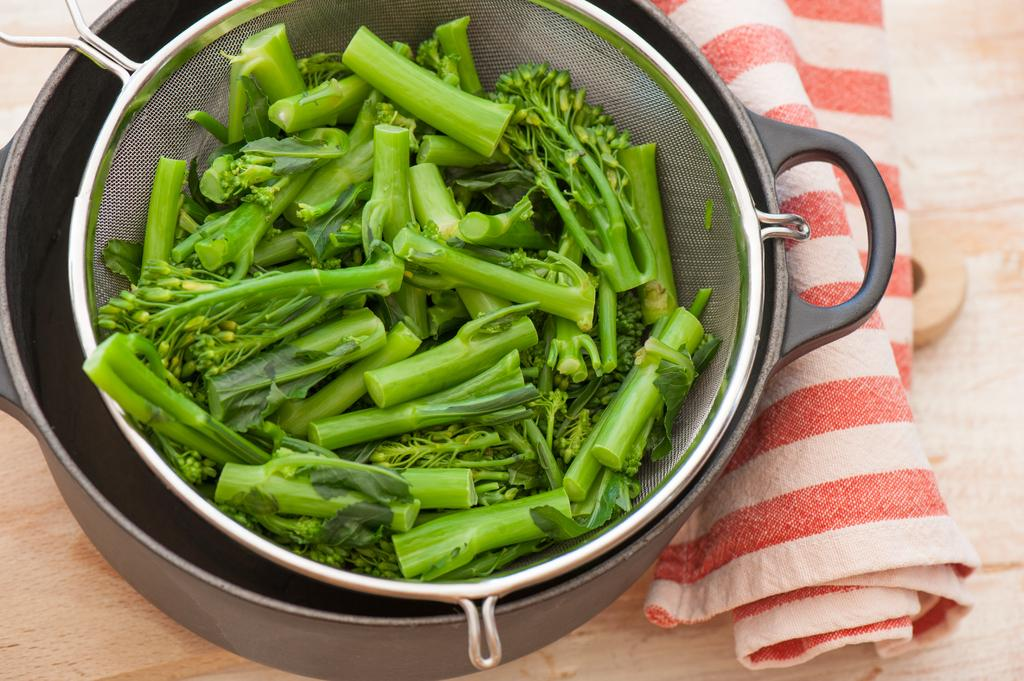What is in the sieve that is visible in the image? There is a sieve containing asparagus in the image. What is located at the bottom of the image? There is a tray at the bottom of the image. What is placed on a wooden surface in the image? A napkin is placed on a wooden surface in the image. What type of coil is present in the image? There is no coil present in the image. Is there a collar visible on any of the objects in the image? No, there is no collar visible in the image. 